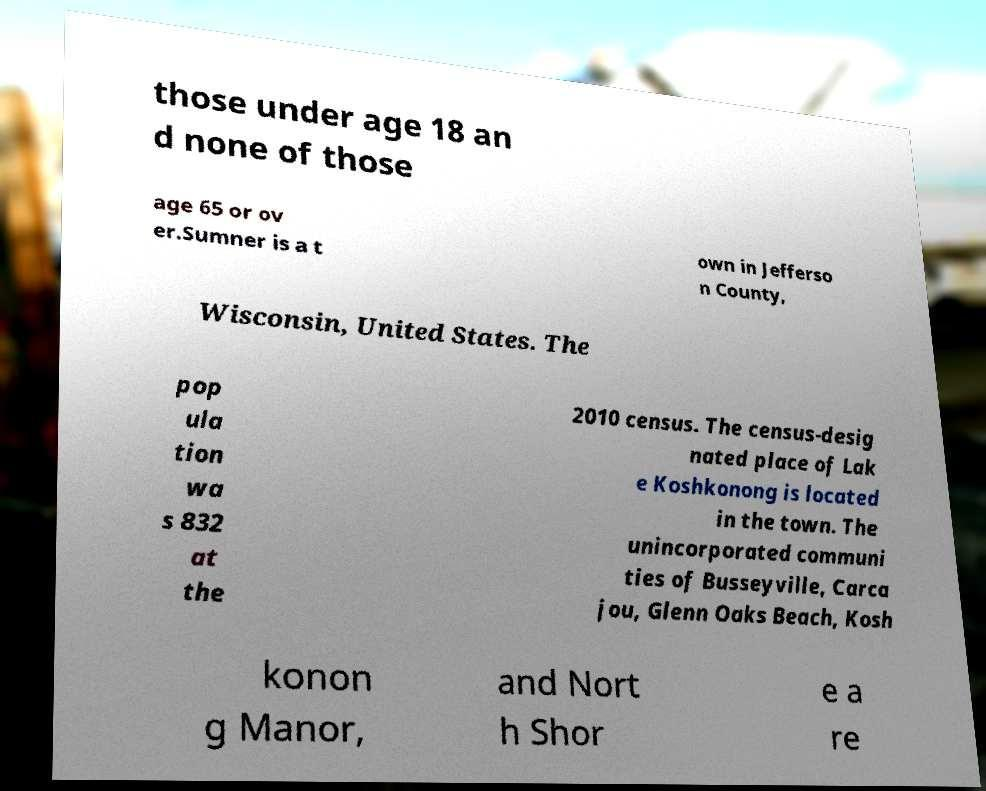Please read and relay the text visible in this image. What does it say? those under age 18 an d none of those age 65 or ov er.Sumner is a t own in Jefferso n County, Wisconsin, United States. The pop ula tion wa s 832 at the 2010 census. The census-desig nated place of Lak e Koshkonong is located in the town. The unincorporated communi ties of Busseyville, Carca jou, Glenn Oaks Beach, Kosh konon g Manor, and Nort h Shor e a re 